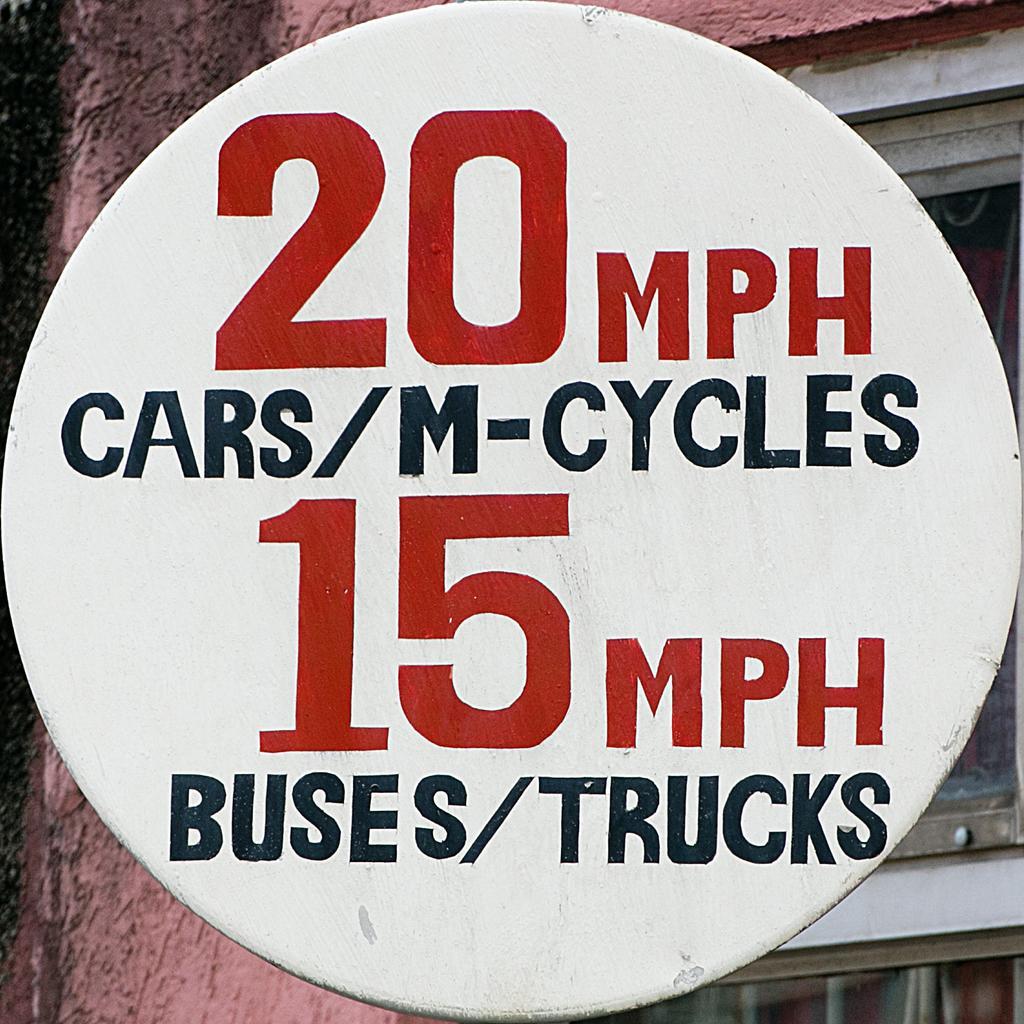How would you summarize this image in a sentence or two? In the image there is a sign board. On the sign board there is something written on it. Behind the pole there is a wall with glass window. 